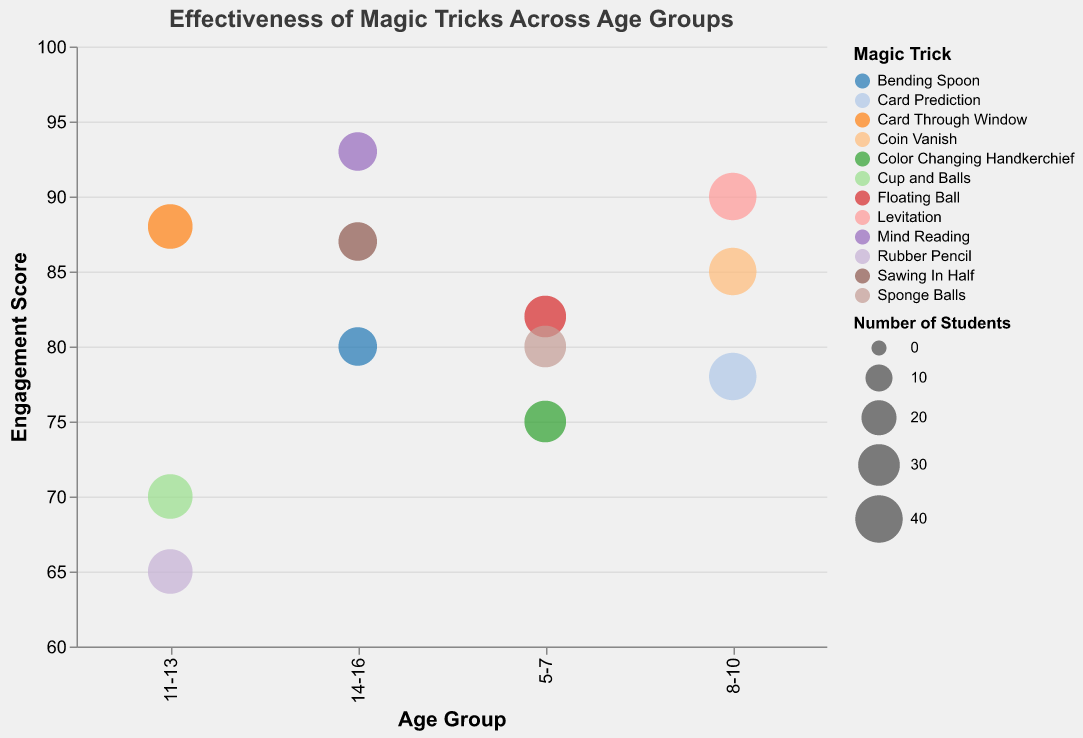Which age group is most engaged with the "Levitation" trick? Look at the "Levitation" trick in the bubble chart and find the corresponding age group.
Answer: 8-10 What is the engagement score for "Mind Reading" for the age group 14-16? Find the bubble representing "Mind Reading" within the age group 14-16 and note its engagement score.
Answer: 93 Among the tricks for the 11-13 age group, which one has the highest engagement score? Compare the engagement scores of "Rubber Pencil," "Card Through Window," and "Cup and Balls" within the 11-13 age group to determine the highest.
Answer: Card Through Window How many students were involved in the "Floating Ball" trick for the age group 5-7? Locate the bubble for "Floating Ball" in the 5-7 age group and note the size of the bubble, which represents the number of students.
Answer: 30 Is the "Coin Vanish" trick more or less engaging than the "Cup and Balls" trick? Compare the engagement scores of "Coin Vanish" and "Cup and Balls."
Answer: More engaging Which magic trick has the highest engagement score across all age groups? Identify the bubble with the highest vertical position (engagement score) within the chart.
Answer: Mind Reading What is the average engagement score for all tricks performed for the 14-16 age group? Sum the engagement scores for "Mind Reading" (93), "Sawing In Half" (87), and "Bending Spoon" (80), then divide by 3 to find the average.  (93+87+80)/3 = 260/3
Answer: 86.7 Which magic trick has the largest number of students in the age group 8-10? Look at the sizes of the bubbles in the 8-10 age group and identify the largest.
Answer: Coin Vanish, Card Prediction, and Levitation What is the difference in engagement score between "Sawing In Half" and "Rubber Pencil"? Subtract the engagement score of "Rubber Pencil" (65) from "Sawing In Half" (87). 87 - 65
Answer: 22 Does the "Sponge Balls" trick have a better engagement score than the "Card Prediction" trick? Compare the engagement scores of "Sponge Balls" (80) and "Card Prediction" (78).
Answer: Yes 